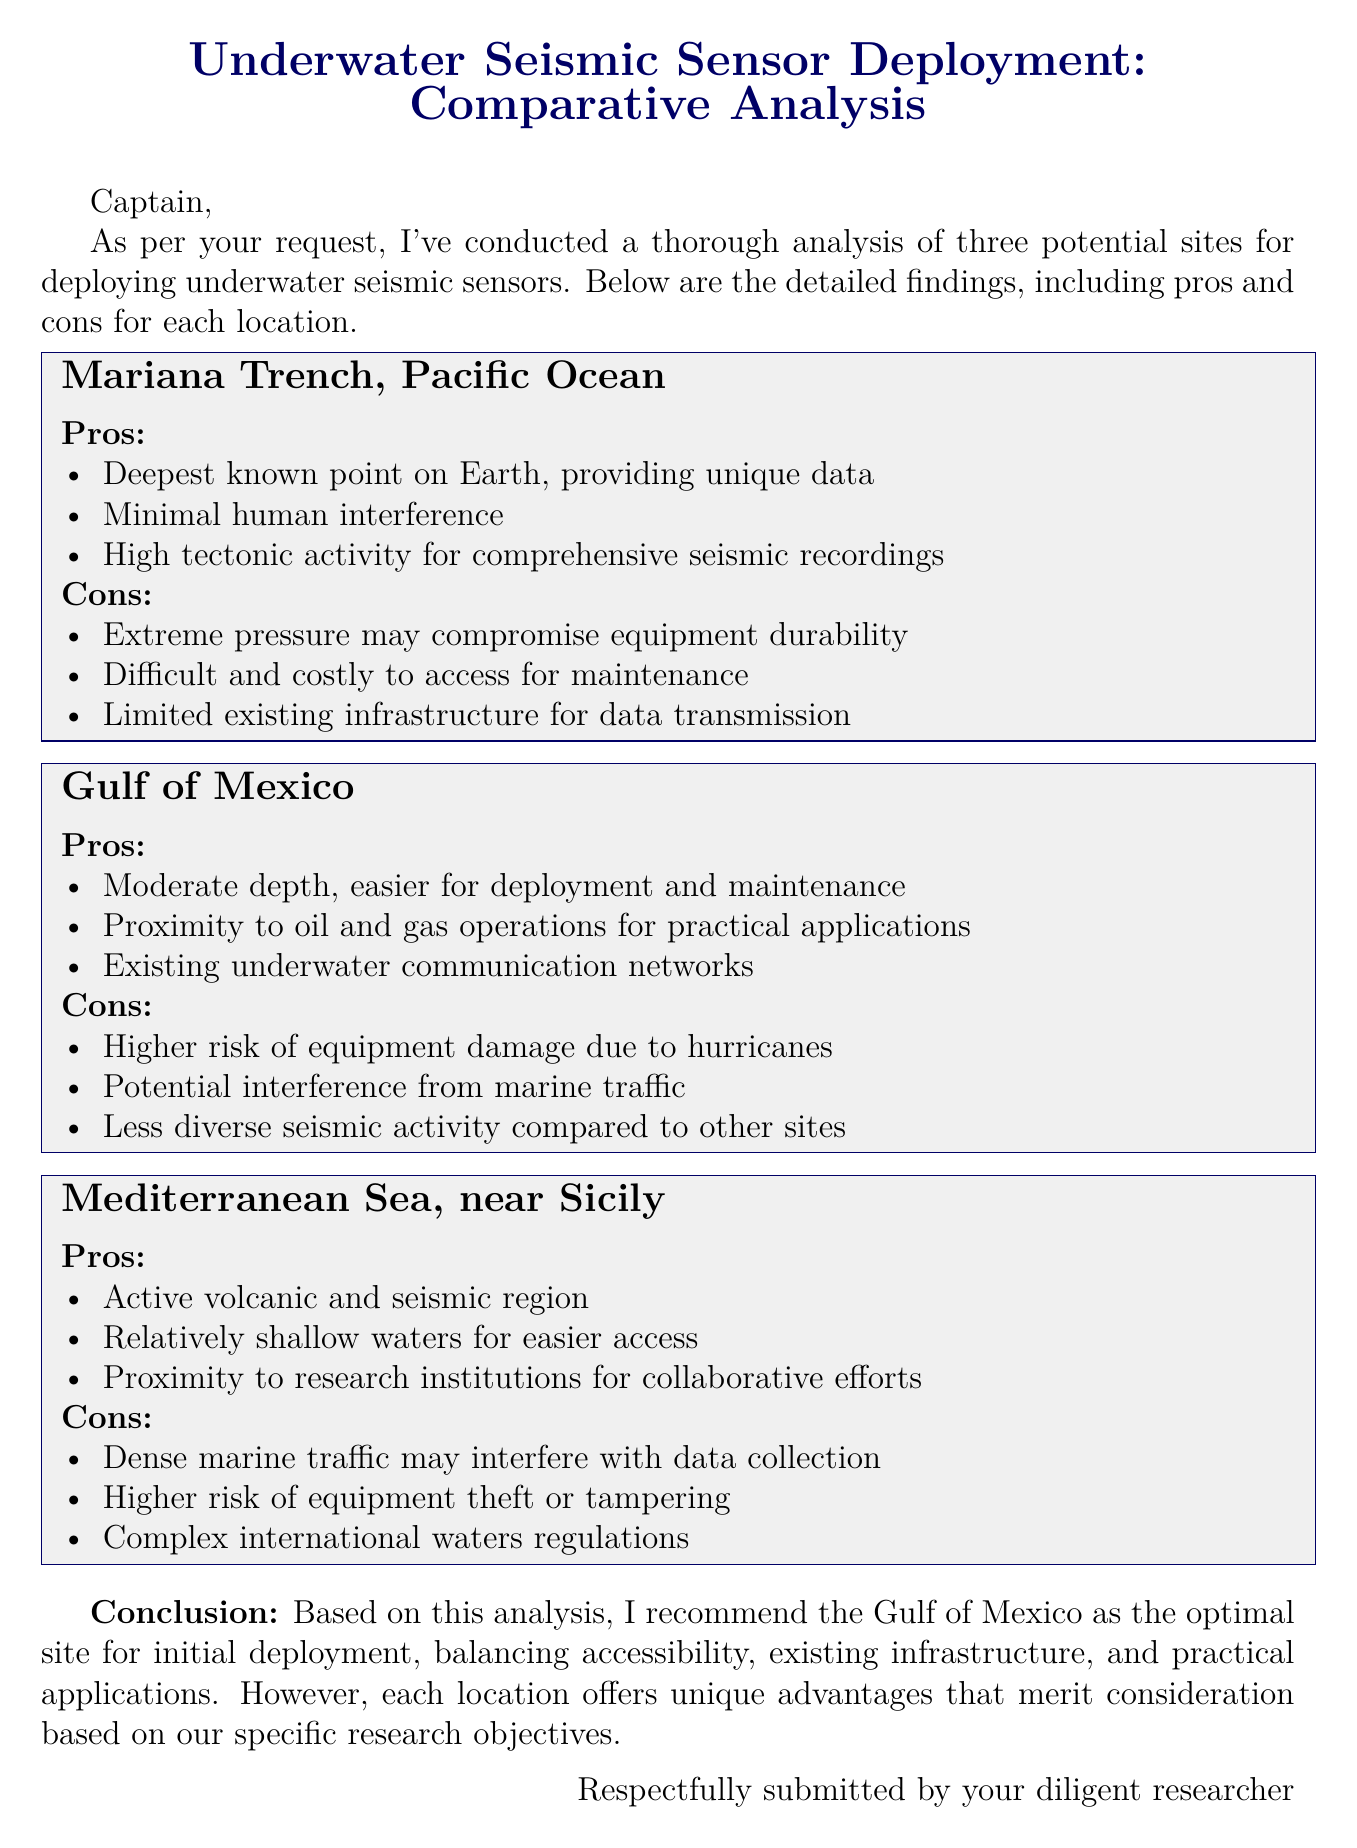What is the title of the document? The title is stated at the top of the document, introducing the subject of the analysis.
Answer: Underwater Seismic Sensor Deployment: Comparative Analysis How many locations are analyzed for sensor deployment? The document lists three potential sites being compared for analysis.
Answer: Three Which site is recommended for initial deployment? The conclusion section states the preferred site for deployment based on the analysis of the pros and cons.
Answer: Gulf of Mexico What is a pro of deploying sensors in the Mariana Trench? The pros section for the Mariana Trench outlines several benefits, one of which is unique data collection due to its deep position.
Answer: Unique data What is a con of deploying sensors in the Mediterranean Sea? One of the cons mentioned for this location refers to potential disruptions from the local conditions.
Answer: Marine traffic What is mentioned as a risk for the Gulf of Mexico? The cons section provides specific risks associated with each site, including environmental threats.
Answer: Hurricanes What type of region is the Mediterranean Sea identified as? The document describes the Mediterranean Sea as having significant geological activity in its pros section.
Answer: Active volcanic and seismic region What is one advantage of the Gulf of Mexico’s location? The document highlights the existing facilities that would facilitate operations in this area as an advantage.
Answer: Existing underwater communication networks 